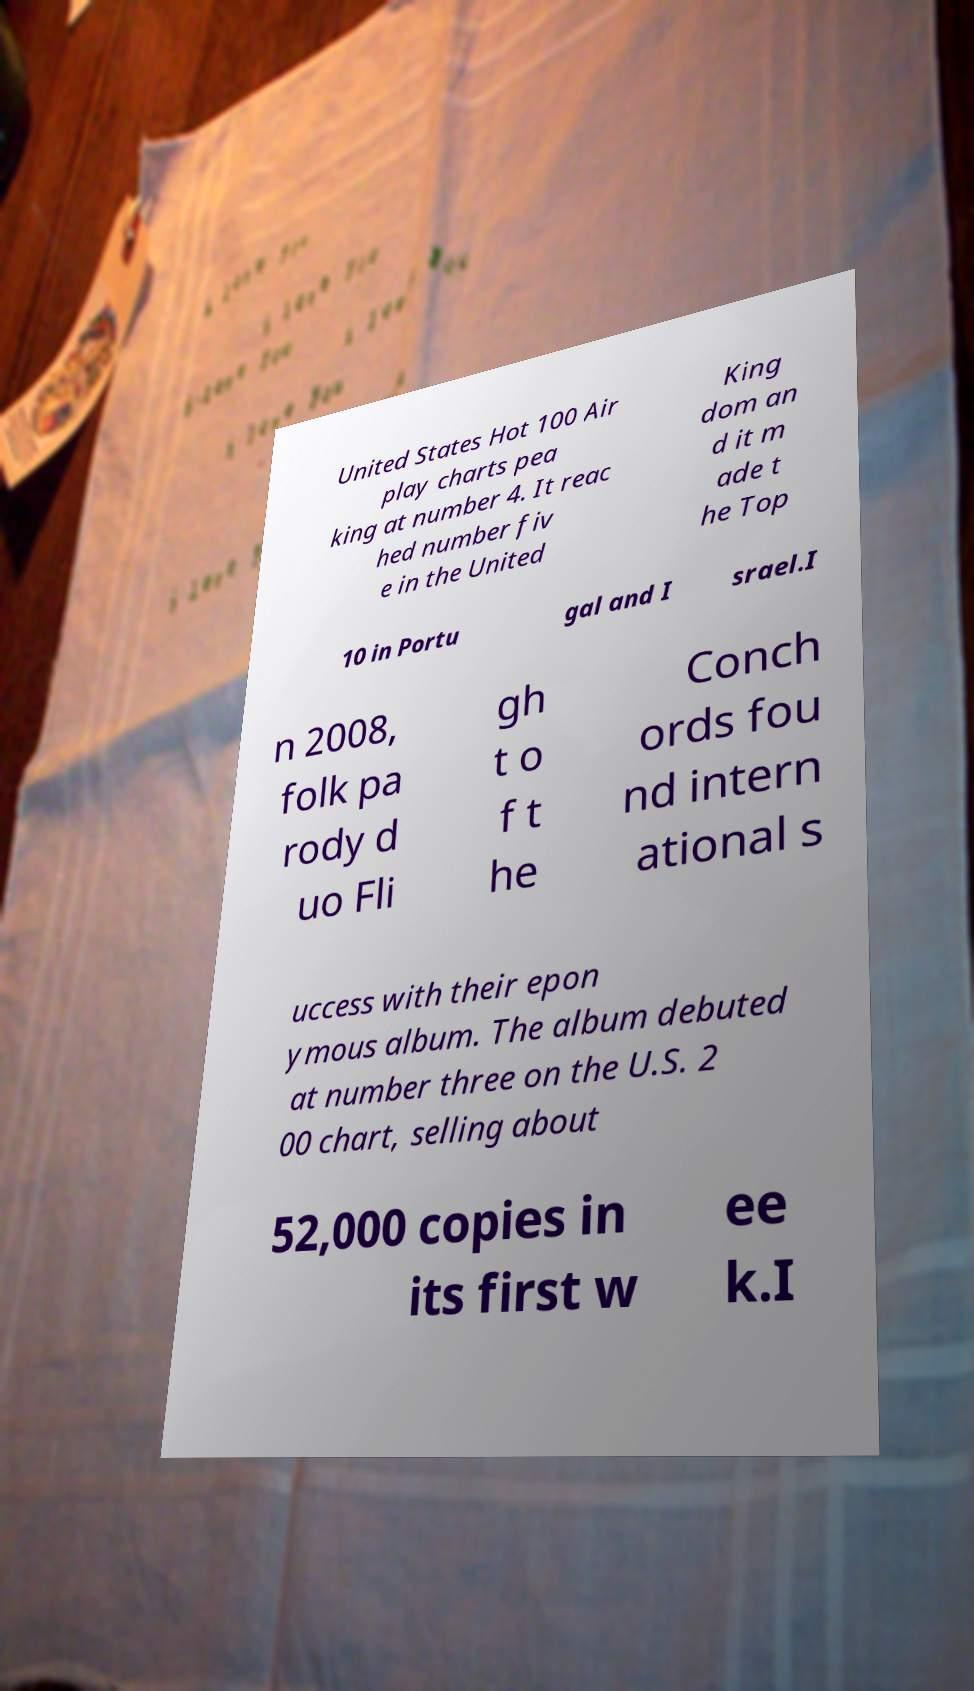Please read and relay the text visible in this image. What does it say? United States Hot 100 Air play charts pea king at number 4. It reac hed number fiv e in the United King dom an d it m ade t he Top 10 in Portu gal and I srael.I n 2008, folk pa rody d uo Fli gh t o f t he Conch ords fou nd intern ational s uccess with their epon ymous album. The album debuted at number three on the U.S. 2 00 chart, selling about 52,000 copies in its first w ee k.I 